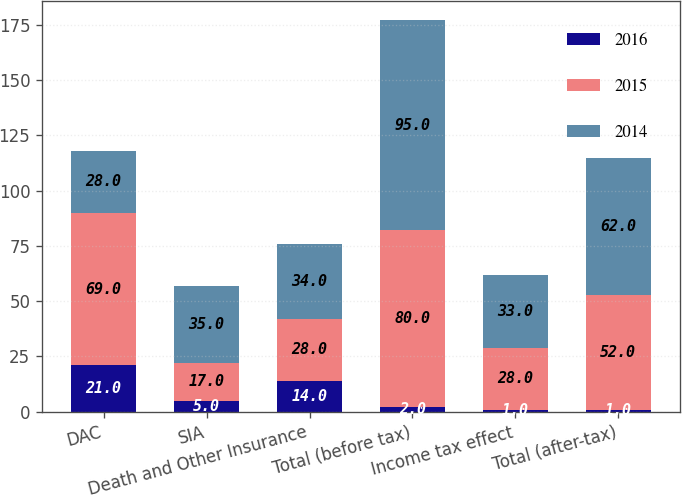<chart> <loc_0><loc_0><loc_500><loc_500><stacked_bar_chart><ecel><fcel>DAC<fcel>SIA<fcel>Death and Other Insurance<fcel>Total (before tax)<fcel>Income tax effect<fcel>Total (after-tax)<nl><fcel>2016<fcel>21<fcel>5<fcel>14<fcel>2<fcel>1<fcel>1<nl><fcel>2015<fcel>69<fcel>17<fcel>28<fcel>80<fcel>28<fcel>52<nl><fcel>2014<fcel>28<fcel>35<fcel>34<fcel>95<fcel>33<fcel>62<nl></chart> 